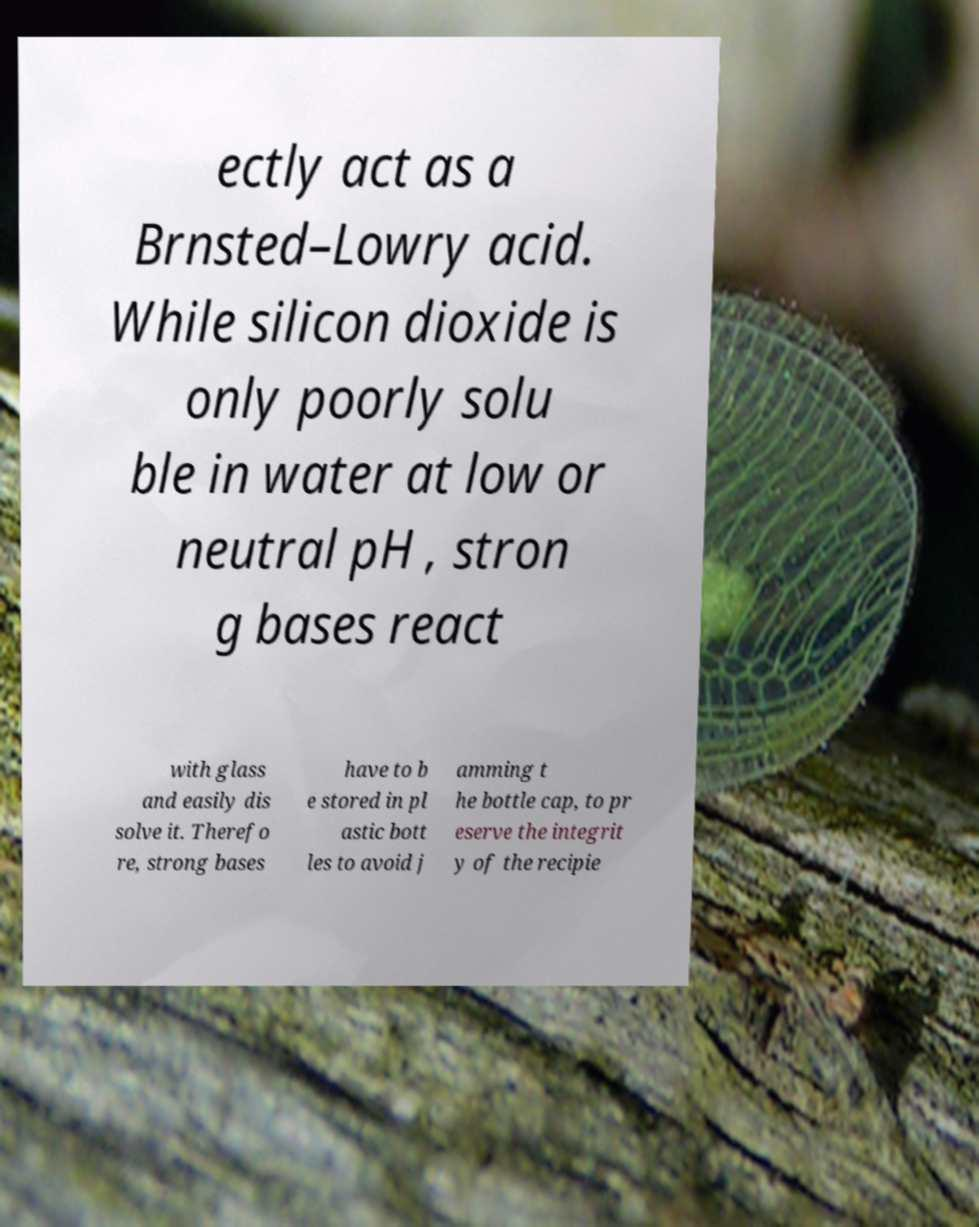Please identify and transcribe the text found in this image. ectly act as a Brnsted–Lowry acid. While silicon dioxide is only poorly solu ble in water at low or neutral pH , stron g bases react with glass and easily dis solve it. Therefo re, strong bases have to b e stored in pl astic bott les to avoid j amming t he bottle cap, to pr eserve the integrit y of the recipie 